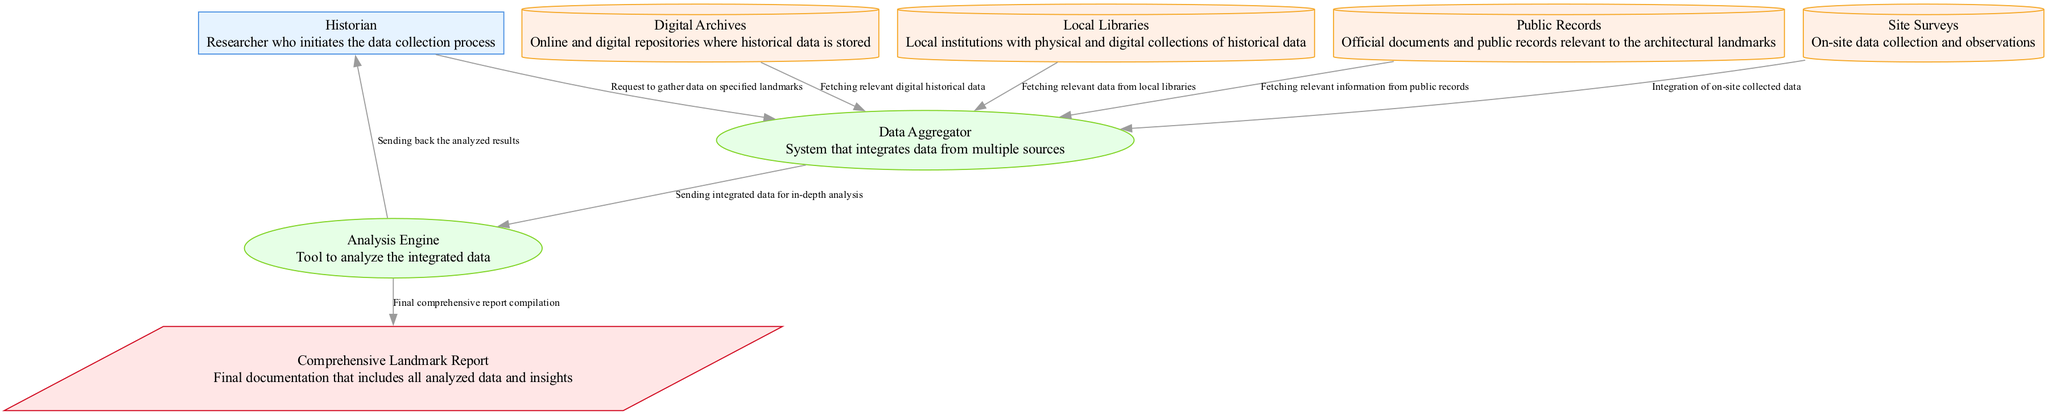What is the primary role of the Historian in this diagram? The Historian initiates the data collection process by sending a research request to the Data Aggregator. This clearly identifies their primary role as the initiator of the data gathering effort.
Answer: Researcher who initiates the data collection process How many data stores are present in the diagram? The diagram lists four data stores: Digital Archives, Local Libraries, Public Records, and Site Surveys, thus verifying that there are four distinct data storage locations for historical data.
Answer: Four Which entity provides the final output of the process? The Comprehensive Landmark Report is the output documented in the diagram; it is generated by the Analysis Engine after analyzing the integrated data. Thus, it is the final deliverable of this process.
Answer: Comprehensive Landmark Report What type of flow connects the Site Surveys to the Data Aggregator? The diagram denotes this connection with an arrow labeled "Survey Data Integration," which falls under the data flow type, indicating that data from Site Surveys are integrated into the Data Aggregator.
Answer: Data flow Where does the analyzed data from the Analysis Engine go? The analyzed data flows back to the Historian from the Analysis Engine, as indicated in the arrow labeled "Analysis Report," confirming that this is the immediate destination for the results of the analysis.
Answer: Historian What is the source of data for the first flow in the diagram? The first flow, titled "ResearchRequest," originates from the Historian, thereby indicating that it is the starting point for data requests in the integration process outlined in the diagram.
Answer: Historian What is the purpose of the Analysis Engine in this context? The Analysis Engine analyzes the integrated data sent from the Data Aggregator, which is critical for generating insights from the collected historical information regarding landmarks.
Answer: Tool to analyze the integrated data How many processes are represented in this diagram? There are two distinct processes represented: Data Aggregator and Analysis Engine, which play essential roles in the integration and analysis of historical data.
Answer: Two 